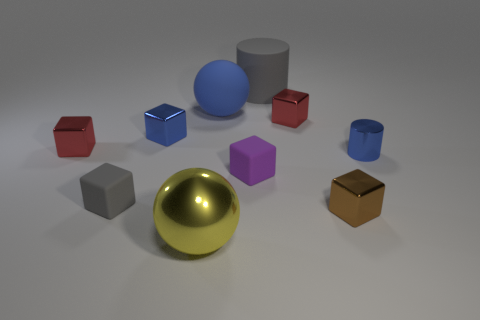Subtract all yellow cylinders. How many red blocks are left? 2 Subtract all small matte blocks. How many blocks are left? 4 Subtract 3 cubes. How many cubes are left? 3 Subtract all blue cubes. How many cubes are left? 5 Subtract all blocks. How many objects are left? 4 Add 3 tiny blue cylinders. How many tiny blue cylinders are left? 4 Add 10 big red shiny cylinders. How many big red shiny cylinders exist? 10 Subtract 0 green cubes. How many objects are left? 10 Subtract all gray spheres. Subtract all cyan blocks. How many spheres are left? 2 Subtract all yellow rubber things. Subtract all tiny gray rubber cubes. How many objects are left? 9 